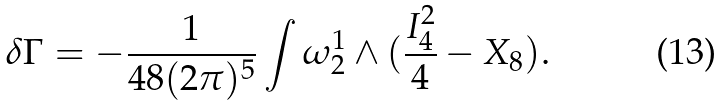Convert formula to latex. <formula><loc_0><loc_0><loc_500><loc_500>\delta \Gamma = - \frac { 1 } { 4 8 ( 2 \pi ) ^ { 5 } } \int \omega _ { 2 } ^ { 1 } \wedge ( \frac { I _ { 4 } ^ { 2 } } { 4 } - X _ { 8 } ) .</formula> 